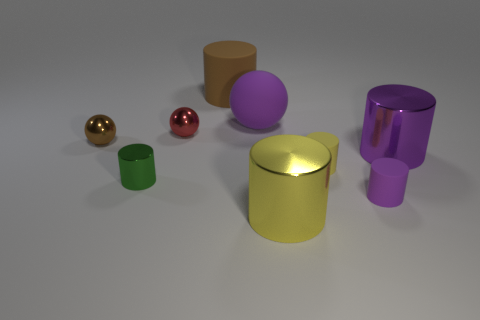Subtract all purple matte balls. How many balls are left? 2 Subtract 3 balls. How many balls are left? 0 Add 1 purple matte balls. How many objects exist? 10 Subtract all purple balls. How many balls are left? 2 Subtract all cylinders. How many objects are left? 3 Subtract all green cylinders. How many red spheres are left? 1 Subtract all tiny brown things. Subtract all small metal spheres. How many objects are left? 6 Add 1 large purple metallic cylinders. How many large purple metallic cylinders are left? 2 Add 5 green things. How many green things exist? 6 Subtract 0 gray cylinders. How many objects are left? 9 